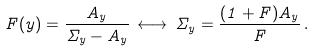Convert formula to latex. <formula><loc_0><loc_0><loc_500><loc_500>F ( y ) = \frac { A _ { y } } { \Sigma _ { y } - A _ { y } } \, \longleftrightarrow \, \Sigma _ { y } = \frac { ( 1 + F ) A _ { y } } { F } \, .</formula> 